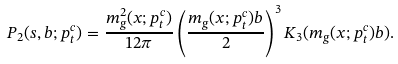<formula> <loc_0><loc_0><loc_500><loc_500>P _ { 2 } ( s , b ; p _ { t } ^ { c } ) = \frac { m _ { g } ^ { 2 } ( x ; p _ { t } ^ { c } ) } { 1 2 \pi } \left ( \frac { m _ { g } ( x ; p _ { t } ^ { c } ) b } { 2 } \right ) ^ { 3 } K _ { 3 } ( m _ { g } ( x ; p _ { t } ^ { c } ) b ) .</formula> 